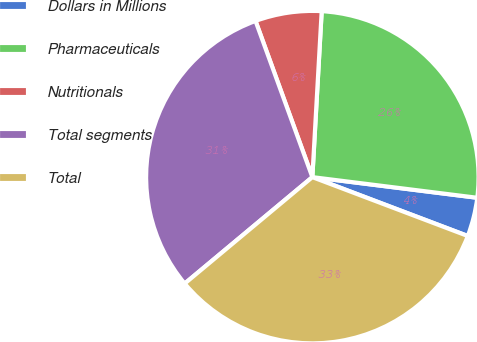Convert chart to OTSL. <chart><loc_0><loc_0><loc_500><loc_500><pie_chart><fcel>Dollars in Millions<fcel>Pharmaceuticals<fcel>Nutritionals<fcel>Total segments<fcel>Total<nl><fcel>3.78%<fcel>26.09%<fcel>6.45%<fcel>30.51%<fcel>33.18%<nl></chart> 